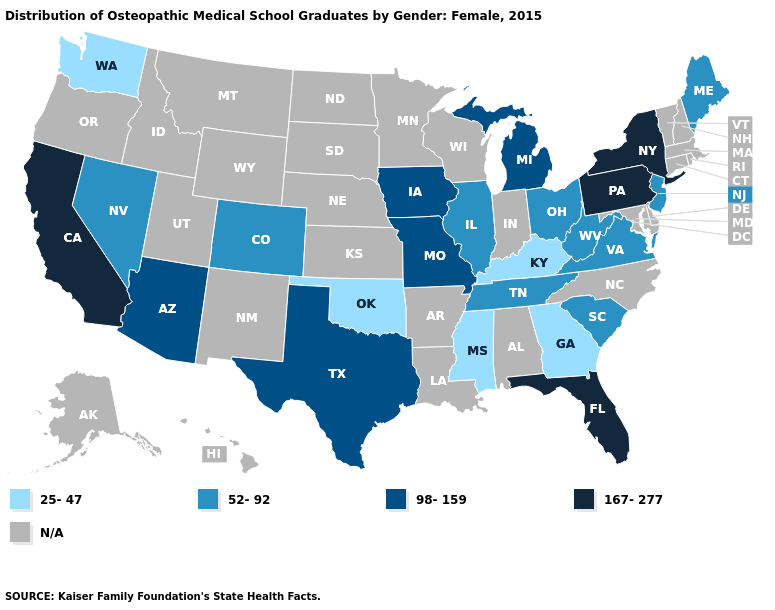What is the value of South Dakota?
Keep it brief. N/A. Does New Jersey have the highest value in the USA?
Keep it brief. No. Name the states that have a value in the range 98-159?
Quick response, please. Arizona, Iowa, Michigan, Missouri, Texas. Which states have the highest value in the USA?
Answer briefly. California, Florida, New York, Pennsylvania. Name the states that have a value in the range 167-277?
Keep it brief. California, Florida, New York, Pennsylvania. What is the value of West Virginia?
Quick response, please. 52-92. What is the highest value in states that border South Dakota?
Be succinct. 98-159. Does California have the highest value in the West?
Quick response, please. Yes. Which states hav the highest value in the South?
Short answer required. Florida. Which states hav the highest value in the Northeast?
Answer briefly. New York, Pennsylvania. What is the value of Arizona?
Keep it brief. 98-159. Does the map have missing data?
Answer briefly. Yes. 